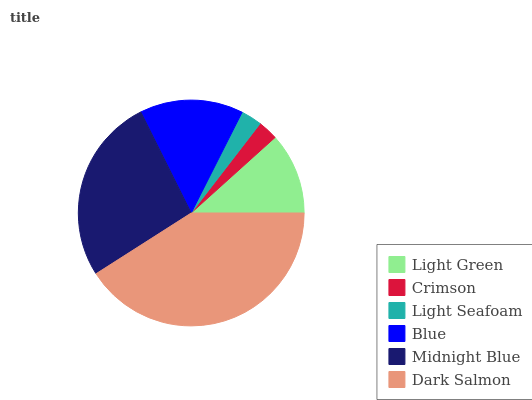Is Crimson the minimum?
Answer yes or no. Yes. Is Dark Salmon the maximum?
Answer yes or no. Yes. Is Light Seafoam the minimum?
Answer yes or no. No. Is Light Seafoam the maximum?
Answer yes or no. No. Is Light Seafoam greater than Crimson?
Answer yes or no. Yes. Is Crimson less than Light Seafoam?
Answer yes or no. Yes. Is Crimson greater than Light Seafoam?
Answer yes or no. No. Is Light Seafoam less than Crimson?
Answer yes or no. No. Is Blue the high median?
Answer yes or no. Yes. Is Light Green the low median?
Answer yes or no. Yes. Is Crimson the high median?
Answer yes or no. No. Is Midnight Blue the low median?
Answer yes or no. No. 